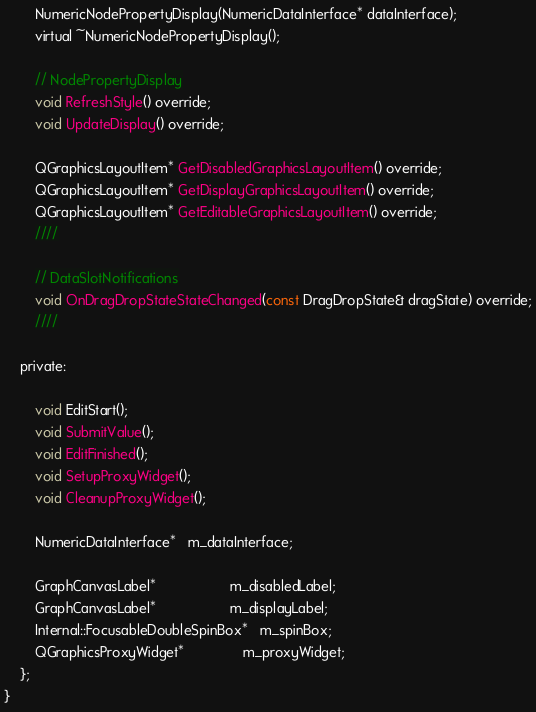<code> <loc_0><loc_0><loc_500><loc_500><_C_>        NumericNodePropertyDisplay(NumericDataInterface* dataInterface);
        virtual ~NumericNodePropertyDisplay();
    
        // NodePropertyDisplay
        void RefreshStyle() override;
        void UpdateDisplay() override;
        
        QGraphicsLayoutItem* GetDisabledGraphicsLayoutItem() override;
        QGraphicsLayoutItem* GetDisplayGraphicsLayoutItem() override;
        QGraphicsLayoutItem* GetEditableGraphicsLayoutItem() override;
        ////

        // DataSlotNotifications
        void OnDragDropStateStateChanged(const DragDropState& dragState) override;
        ////
    
    private:

        void EditStart();
        void SubmitValue();
        void EditFinished();
        void SetupProxyWidget();
        void CleanupProxyWidget();
    
        NumericDataInterface*   m_dataInterface;
    
        GraphCanvasLabel*                   m_disabledLabel;
        GraphCanvasLabel*                   m_displayLabel;
        Internal::FocusableDoubleSpinBox*   m_spinBox;
        QGraphicsProxyWidget*               m_proxyWidget;
    };
}
</code> 